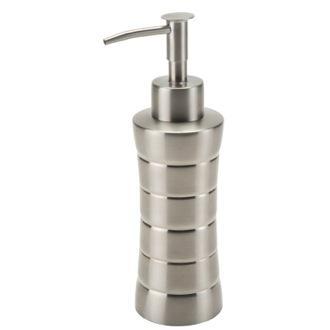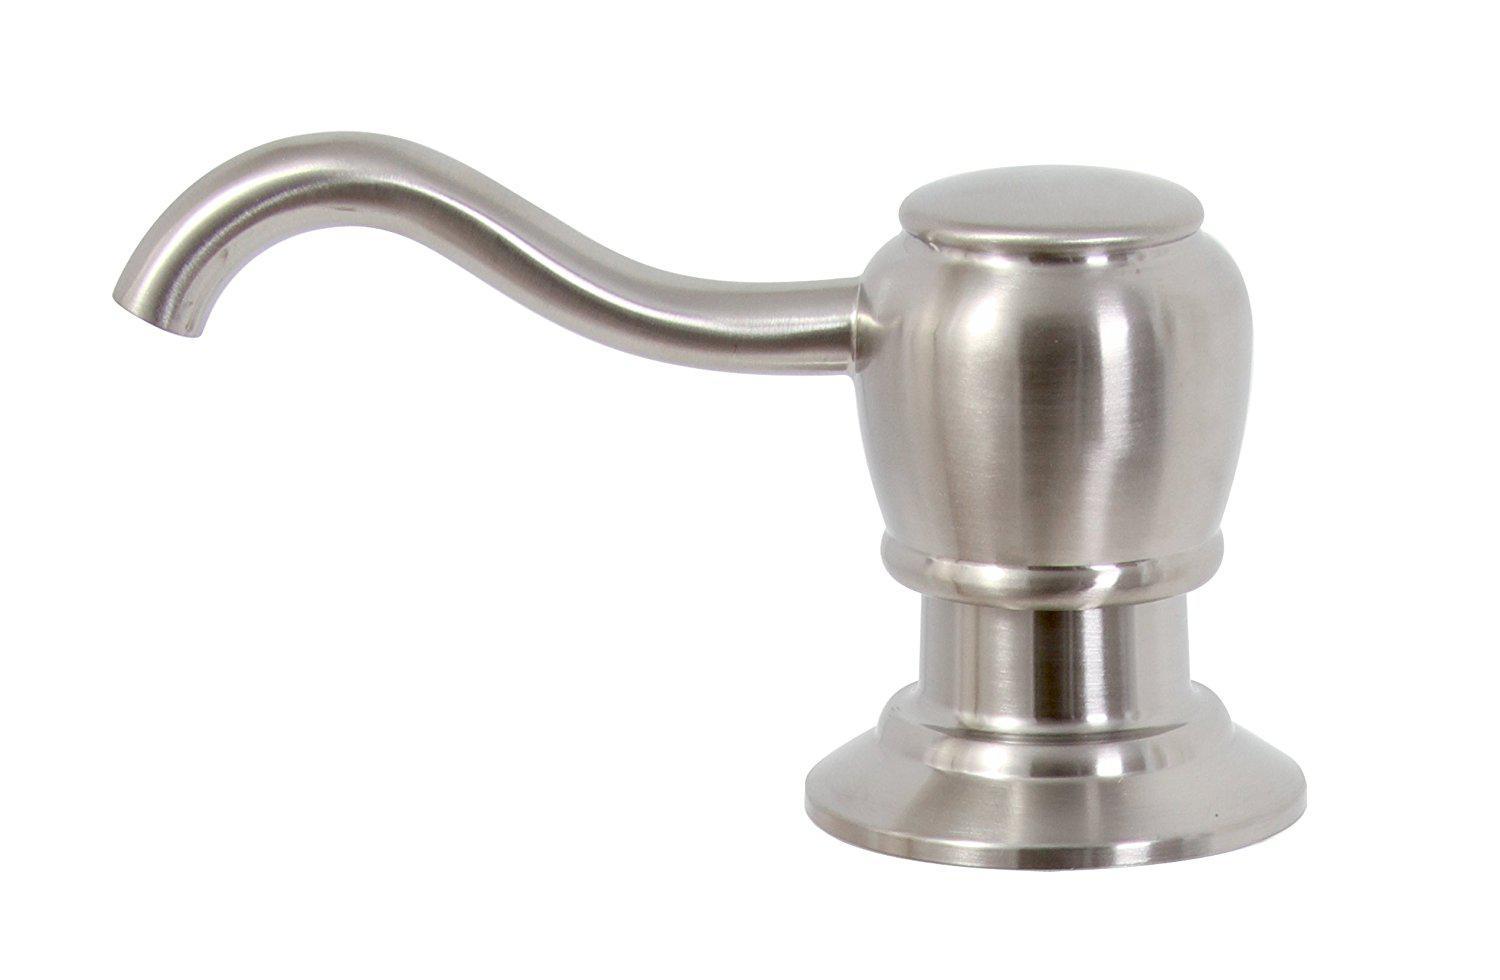The first image is the image on the left, the second image is the image on the right. Examine the images to the left and right. Is the description "The pump on the left is not connected to a container." accurate? Answer yes or no. No. 